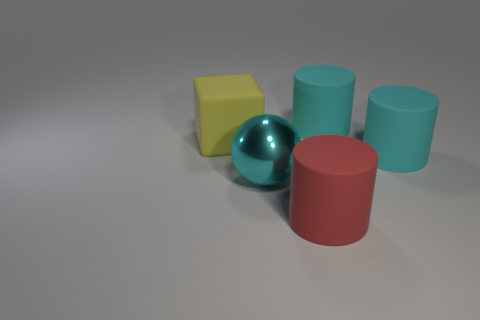There is a big rubber object behind the thing that is on the left side of the big shiny sphere; what color is it?
Offer a very short reply. Cyan. There is a cyan metal object; is it the same shape as the thing to the left of the large shiny ball?
Ensure brevity in your answer.  No. How many blocks are the same size as the red rubber object?
Make the answer very short. 1. There is a cylinder behind the large yellow rubber cube; does it have the same color as the rubber thing that is on the left side of the large red matte cylinder?
Make the answer very short. No. There is a big cyan thing on the left side of the red cylinder; what shape is it?
Your answer should be compact. Sphere. The matte block has what color?
Your answer should be very brief. Yellow. There is a yellow object that is the same material as the red object; what shape is it?
Ensure brevity in your answer.  Cube. There is a rubber thing that is left of the red matte object; does it have the same size as the cyan metal thing?
Provide a short and direct response. Yes. What number of things are rubber things that are right of the cyan metal ball or big rubber things that are on the left side of the large cyan sphere?
Offer a very short reply. 4. Do the large thing that is in front of the metallic sphere and the sphere have the same color?
Your answer should be very brief. No. 